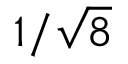<formula> <loc_0><loc_0><loc_500><loc_500>1 / { \sqrt { 8 } }</formula> 